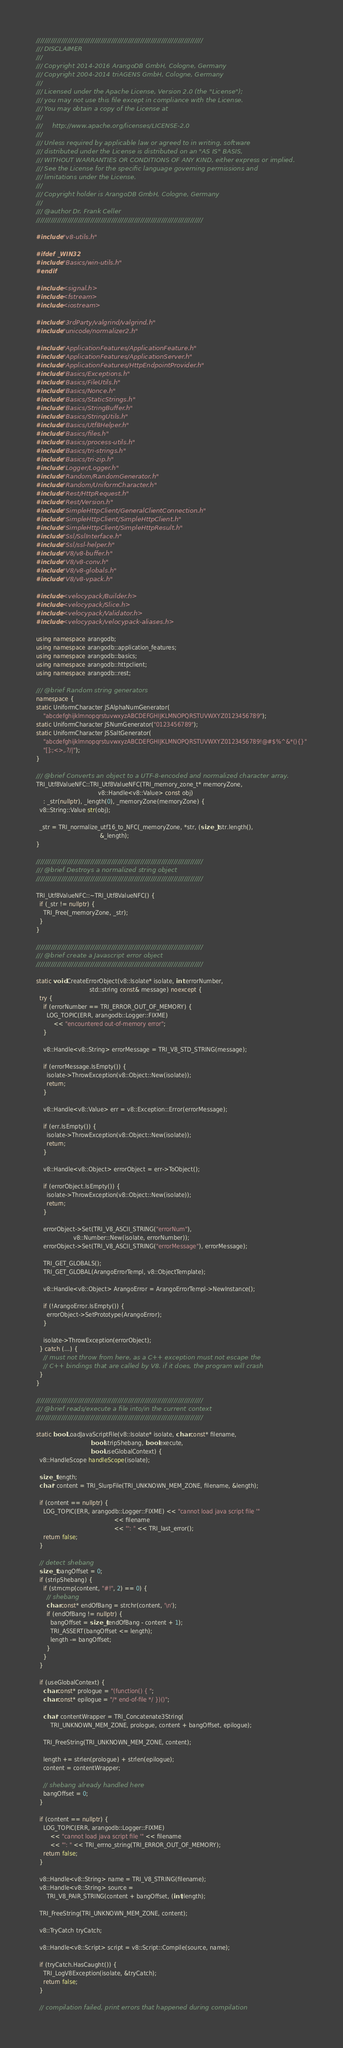<code> <loc_0><loc_0><loc_500><loc_500><_C++_>////////////////////////////////////////////////////////////////////////////////
/// DISCLAIMER
///
/// Copyright 2014-2016 ArangoDB GmbH, Cologne, Germany
/// Copyright 2004-2014 triAGENS GmbH, Cologne, Germany
///
/// Licensed under the Apache License, Version 2.0 (the "License");
/// you may not use this file except in compliance with the License.
/// You may obtain a copy of the License at
///
///     http://www.apache.org/licenses/LICENSE-2.0
///
/// Unless required by applicable law or agreed to in writing, software
/// distributed under the License is distributed on an "AS IS" BASIS,
/// WITHOUT WARRANTIES OR CONDITIONS OF ANY KIND, either express or implied.
/// See the License for the specific language governing permissions and
/// limitations under the License.
///
/// Copyright holder is ArangoDB GmbH, Cologne, Germany
///
/// @author Dr. Frank Celler
////////////////////////////////////////////////////////////////////////////////

#include "v8-utils.h"

#ifdef _WIN32
#include "Basics/win-utils.h"
#endif

#include <signal.h>
#include <fstream>
#include <iostream>

#include "3rdParty/valgrind/valgrind.h"
#include "unicode/normalizer2.h"

#include "ApplicationFeatures/ApplicationFeature.h"
#include "ApplicationFeatures/ApplicationServer.h"
#include "ApplicationFeatures/HttpEndpointProvider.h"
#include "Basics/Exceptions.h"
#include "Basics/FileUtils.h"
#include "Basics/Nonce.h"
#include "Basics/StaticStrings.h"
#include "Basics/StringBuffer.h"
#include "Basics/StringUtils.h"
#include "Basics/Utf8Helper.h"
#include "Basics/files.h"
#include "Basics/process-utils.h"
#include "Basics/tri-strings.h"
#include "Basics/tri-zip.h"
#include "Logger/Logger.h"
#include "Random/RandomGenerator.h"
#include "Random/UniformCharacter.h"
#include "Rest/HttpRequest.h"
#include "Rest/Version.h"
#include "SimpleHttpClient/GeneralClientConnection.h"
#include "SimpleHttpClient/SimpleHttpClient.h"
#include "SimpleHttpClient/SimpleHttpResult.h"
#include "Ssl/SslInterface.h"
#include "Ssl/ssl-helper.h"
#include "V8/v8-buffer.h"
#include "V8/v8-conv.h"
#include "V8/v8-globals.h"
#include "V8/v8-vpack.h"

#include <velocypack/Builder.h>
#include <velocypack/Slice.h>
#include <velocypack/Validator.h>
#include <velocypack/velocypack-aliases.h>

using namespace arangodb;
using namespace arangodb::application_features;
using namespace arangodb::basics;
using namespace arangodb::httpclient;
using namespace arangodb::rest;

/// @brief Random string generators
namespace {
static UniformCharacter JSAlphaNumGenerator(
    "abcdefghijklmnopqrstuvwxyzABCDEFGHIJKLMNOPQRSTUVWXYZ0123456789");
static UniformCharacter JSNumGenerator("0123456789");
static UniformCharacter JSSaltGenerator(
    "abcdefghijklmnopqrstuvwxyzABCDEFGHIJKLMNOPQRSTUVWXYZ0123456789!@#$%^&*(){}"
    "[]:;<>,.?/|");
}

/// @brief Converts an object to a UTF-8-encoded and normalized character array.
TRI_Utf8ValueNFC::TRI_Utf8ValueNFC(TRI_memory_zone_t* memoryZone,
                                   v8::Handle<v8::Value> const obj)
    : _str(nullptr), _length(0), _memoryZone(memoryZone) {
  v8::String::Value str(obj);

  _str = TRI_normalize_utf16_to_NFC(_memoryZone, *str, (size_t)str.length(),
                                    &_length);
}

////////////////////////////////////////////////////////////////////////////////
/// @brief Destroys a normalized string object
////////////////////////////////////////////////////////////////////////////////

TRI_Utf8ValueNFC::~TRI_Utf8ValueNFC() {
  if (_str != nullptr) {
    TRI_Free(_memoryZone, _str);
  }
}

////////////////////////////////////////////////////////////////////////////////
/// @brief create a Javascript error object
////////////////////////////////////////////////////////////////////////////////

static void CreateErrorObject(v8::Isolate* isolate, int errorNumber,
                              std::string const& message) noexcept {
  try {
    if (errorNumber == TRI_ERROR_OUT_OF_MEMORY) {
      LOG_TOPIC(ERR, arangodb::Logger::FIXME)
          << "encountered out-of-memory error";
    }

    v8::Handle<v8::String> errorMessage = TRI_V8_STD_STRING(message);

    if (errorMessage.IsEmpty()) {
      isolate->ThrowException(v8::Object::New(isolate));
      return;
    }

    v8::Handle<v8::Value> err = v8::Exception::Error(errorMessage);

    if (err.IsEmpty()) {
      isolate->ThrowException(v8::Object::New(isolate));
      return;
    }

    v8::Handle<v8::Object> errorObject = err->ToObject();

    if (errorObject.IsEmpty()) {
      isolate->ThrowException(v8::Object::New(isolate));
      return;
    }

    errorObject->Set(TRI_V8_ASCII_STRING("errorNum"),
                     v8::Number::New(isolate, errorNumber));
    errorObject->Set(TRI_V8_ASCII_STRING("errorMessage"), errorMessage);

    TRI_GET_GLOBALS();
    TRI_GET_GLOBAL(ArangoErrorTempl, v8::ObjectTemplate);

    v8::Handle<v8::Object> ArangoError = ArangoErrorTempl->NewInstance();

    if (!ArangoError.IsEmpty()) {
      errorObject->SetPrototype(ArangoError);
    }

    isolate->ThrowException(errorObject);
  } catch (...) {
    // must not throw from here, as a C++ exception must not escape the
    // C++ bindings that are called by V8. if it does, the program will crash
  }
}

////////////////////////////////////////////////////////////////////////////////
/// @brief reads/execute a file into/in the current context
////////////////////////////////////////////////////////////////////////////////

static bool LoadJavaScriptFile(v8::Isolate* isolate, char const* filename,
                               bool stripShebang, bool execute,
                               bool useGlobalContext) {
  v8::HandleScope handleScope(isolate);

  size_t length;
  char* content = TRI_SlurpFile(TRI_UNKNOWN_MEM_ZONE, filename, &length);

  if (content == nullptr) {
    LOG_TOPIC(ERR, arangodb::Logger::FIXME) << "cannot load java script file '"
                                            << filename
                                            << "': " << TRI_last_error();
    return false;
  }

  // detect shebang
  size_t bangOffset = 0;
  if (stripShebang) {
    if (strncmp(content, "#!", 2) == 0) {
      // shebang
      char const* endOfBang = strchr(content, '\n');
      if (endOfBang != nullptr) {
        bangOffset = size_t(endOfBang - content + 1);
        TRI_ASSERT(bangOffset <= length);
        length -= bangOffset;
      }
    }
  }

  if (useGlobalContext) {
    char const* prologue = "(function() { ";
    char const* epilogue = "/* end-of-file */ })()";

    char* contentWrapper = TRI_Concatenate3String(
        TRI_UNKNOWN_MEM_ZONE, prologue, content + bangOffset, epilogue);

    TRI_FreeString(TRI_UNKNOWN_MEM_ZONE, content);

    length += strlen(prologue) + strlen(epilogue);
    content = contentWrapper;

    // shebang already handled here
    bangOffset = 0;
  }

  if (content == nullptr) {
    LOG_TOPIC(ERR, arangodb::Logger::FIXME)
        << "cannot load java script file '" << filename
        << "': " << TRI_errno_string(TRI_ERROR_OUT_OF_MEMORY);
    return false;
  }

  v8::Handle<v8::String> name = TRI_V8_STRING(filename);
  v8::Handle<v8::String> source =
      TRI_V8_PAIR_STRING(content + bangOffset, (int)length);

  TRI_FreeString(TRI_UNKNOWN_MEM_ZONE, content);

  v8::TryCatch tryCatch;

  v8::Handle<v8::Script> script = v8::Script::Compile(source, name);

  if (tryCatch.HasCaught()) {
    TRI_LogV8Exception(isolate, &tryCatch);
    return false;
  }

  // compilation failed, print errors that happened during compilation</code> 